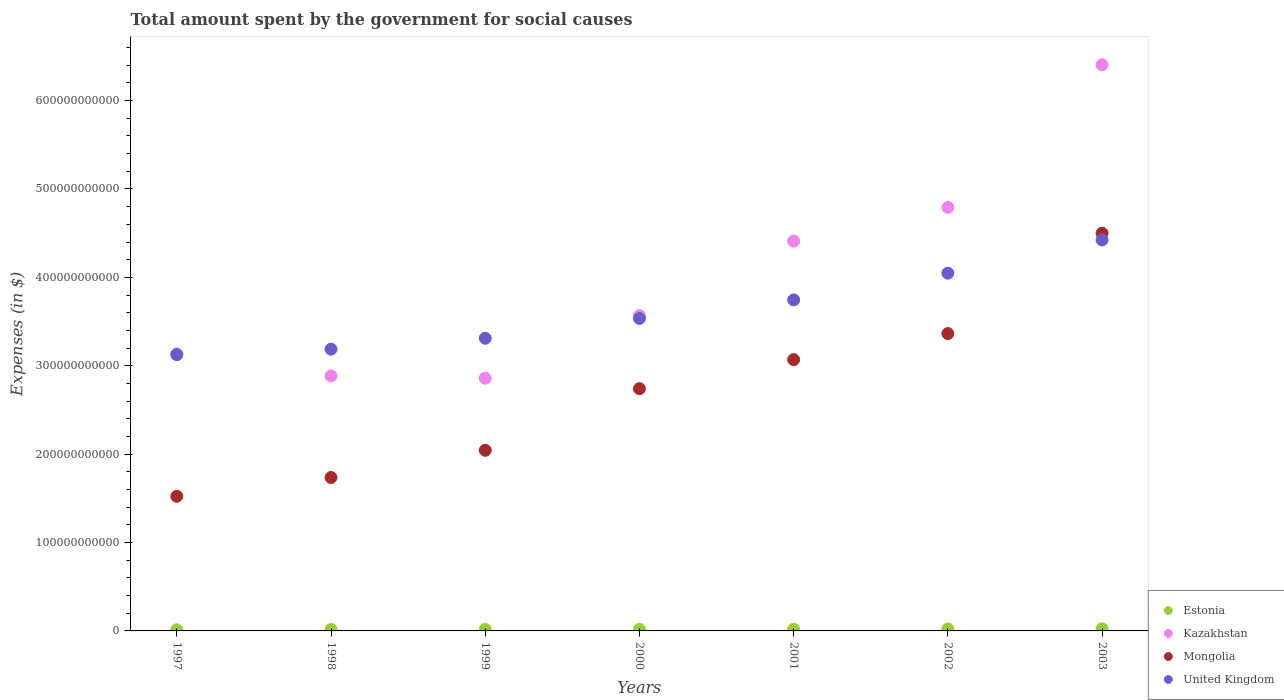How many different coloured dotlines are there?
Offer a very short reply. 4. Is the number of dotlines equal to the number of legend labels?
Give a very brief answer. Yes. What is the amount spent for social causes by the government in Mongolia in 1999?
Provide a succinct answer. 2.04e+11. Across all years, what is the maximum amount spent for social causes by the government in Estonia?
Give a very brief answer. 2.40e+09. Across all years, what is the minimum amount spent for social causes by the government in United Kingdom?
Offer a very short reply. 3.13e+11. In which year was the amount spent for social causes by the government in Kazakhstan maximum?
Ensure brevity in your answer.  2003. What is the total amount spent for social causes by the government in Estonia in the graph?
Your answer should be compact. 1.29e+1. What is the difference between the amount spent for social causes by the government in Kazakhstan in 2000 and that in 2001?
Offer a terse response. -8.43e+1. What is the difference between the amount spent for social causes by the government in Mongolia in 1998 and the amount spent for social causes by the government in Estonia in 2002?
Your answer should be compact. 1.71e+11. What is the average amount spent for social causes by the government in United Kingdom per year?
Ensure brevity in your answer.  3.63e+11. In the year 1997, what is the difference between the amount spent for social causes by the government in Estonia and amount spent for social causes by the government in Kazakhstan?
Your answer should be very brief. -3.12e+11. What is the ratio of the amount spent for social causes by the government in Estonia in 1998 to that in 2002?
Ensure brevity in your answer.  0.73. Is the difference between the amount spent for social causes by the government in Estonia in 1998 and 1999 greater than the difference between the amount spent for social causes by the government in Kazakhstan in 1998 and 1999?
Keep it short and to the point. No. What is the difference between the highest and the second highest amount spent for social causes by the government in United Kingdom?
Ensure brevity in your answer.  3.76e+1. What is the difference between the highest and the lowest amount spent for social causes by the government in Kazakhstan?
Provide a short and direct response. 3.54e+11. Is it the case that in every year, the sum of the amount spent for social causes by the government in Kazakhstan and amount spent for social causes by the government in United Kingdom  is greater than the sum of amount spent for social causes by the government in Estonia and amount spent for social causes by the government in Mongolia?
Your answer should be very brief. Yes. Is it the case that in every year, the sum of the amount spent for social causes by the government in Kazakhstan and amount spent for social causes by the government in Estonia  is greater than the amount spent for social causes by the government in United Kingdom?
Your answer should be compact. No. Is the amount spent for social causes by the government in Kazakhstan strictly greater than the amount spent for social causes by the government in Estonia over the years?
Make the answer very short. Yes. How many dotlines are there?
Provide a short and direct response. 4. How many years are there in the graph?
Offer a terse response. 7. What is the difference between two consecutive major ticks on the Y-axis?
Your answer should be very brief. 1.00e+11. Does the graph contain grids?
Keep it short and to the point. No. Where does the legend appear in the graph?
Provide a succinct answer. Bottom right. How are the legend labels stacked?
Offer a very short reply. Vertical. What is the title of the graph?
Offer a terse response. Total amount spent by the government for social causes. Does "South Africa" appear as one of the legend labels in the graph?
Your answer should be very brief. No. What is the label or title of the X-axis?
Keep it short and to the point. Years. What is the label or title of the Y-axis?
Offer a very short reply. Expenses (in $). What is the Expenses (in $) of Estonia in 1997?
Your response must be concise. 1.33e+09. What is the Expenses (in $) of Kazakhstan in 1997?
Provide a short and direct response. 3.13e+11. What is the Expenses (in $) in Mongolia in 1997?
Your response must be concise. 1.52e+11. What is the Expenses (in $) of United Kingdom in 1997?
Offer a very short reply. 3.13e+11. What is the Expenses (in $) of Estonia in 1998?
Give a very brief answer. 1.56e+09. What is the Expenses (in $) of Kazakhstan in 1998?
Ensure brevity in your answer.  2.89e+11. What is the Expenses (in $) in Mongolia in 1998?
Offer a terse response. 1.74e+11. What is the Expenses (in $) of United Kingdom in 1998?
Give a very brief answer. 3.19e+11. What is the Expenses (in $) in Estonia in 1999?
Provide a short and direct response. 1.75e+09. What is the Expenses (in $) of Kazakhstan in 1999?
Provide a short and direct response. 2.86e+11. What is the Expenses (in $) of Mongolia in 1999?
Ensure brevity in your answer.  2.04e+11. What is the Expenses (in $) in United Kingdom in 1999?
Give a very brief answer. 3.31e+11. What is the Expenses (in $) of Estonia in 2000?
Give a very brief answer. 1.82e+09. What is the Expenses (in $) in Kazakhstan in 2000?
Your answer should be very brief. 3.57e+11. What is the Expenses (in $) of Mongolia in 2000?
Provide a short and direct response. 2.74e+11. What is the Expenses (in $) in United Kingdom in 2000?
Your answer should be very brief. 3.54e+11. What is the Expenses (in $) of Estonia in 2001?
Ensure brevity in your answer.  1.93e+09. What is the Expenses (in $) of Kazakhstan in 2001?
Offer a terse response. 4.41e+11. What is the Expenses (in $) of Mongolia in 2001?
Offer a very short reply. 3.07e+11. What is the Expenses (in $) in United Kingdom in 2001?
Give a very brief answer. 3.75e+11. What is the Expenses (in $) of Estonia in 2002?
Provide a short and direct response. 2.15e+09. What is the Expenses (in $) in Kazakhstan in 2002?
Offer a very short reply. 4.79e+11. What is the Expenses (in $) in Mongolia in 2002?
Provide a succinct answer. 3.36e+11. What is the Expenses (in $) of United Kingdom in 2002?
Provide a succinct answer. 4.05e+11. What is the Expenses (in $) in Estonia in 2003?
Your answer should be very brief. 2.40e+09. What is the Expenses (in $) of Kazakhstan in 2003?
Keep it short and to the point. 6.40e+11. What is the Expenses (in $) of Mongolia in 2003?
Provide a short and direct response. 4.50e+11. What is the Expenses (in $) in United Kingdom in 2003?
Ensure brevity in your answer.  4.42e+11. Across all years, what is the maximum Expenses (in $) in Estonia?
Ensure brevity in your answer.  2.40e+09. Across all years, what is the maximum Expenses (in $) of Kazakhstan?
Provide a succinct answer. 6.40e+11. Across all years, what is the maximum Expenses (in $) in Mongolia?
Give a very brief answer. 4.50e+11. Across all years, what is the maximum Expenses (in $) of United Kingdom?
Keep it short and to the point. 4.42e+11. Across all years, what is the minimum Expenses (in $) of Estonia?
Offer a very short reply. 1.33e+09. Across all years, what is the minimum Expenses (in $) in Kazakhstan?
Keep it short and to the point. 2.86e+11. Across all years, what is the minimum Expenses (in $) of Mongolia?
Your answer should be very brief. 1.52e+11. Across all years, what is the minimum Expenses (in $) of United Kingdom?
Your response must be concise. 3.13e+11. What is the total Expenses (in $) of Estonia in the graph?
Keep it short and to the point. 1.29e+1. What is the total Expenses (in $) of Kazakhstan in the graph?
Your response must be concise. 2.81e+12. What is the total Expenses (in $) in Mongolia in the graph?
Offer a terse response. 1.90e+12. What is the total Expenses (in $) of United Kingdom in the graph?
Give a very brief answer. 2.54e+12. What is the difference between the Expenses (in $) of Estonia in 1997 and that in 1998?
Ensure brevity in your answer.  -2.32e+08. What is the difference between the Expenses (in $) of Kazakhstan in 1997 and that in 1998?
Your answer should be compact. 2.49e+1. What is the difference between the Expenses (in $) in Mongolia in 1997 and that in 1998?
Provide a short and direct response. -2.12e+1. What is the difference between the Expenses (in $) of United Kingdom in 1997 and that in 1998?
Provide a succinct answer. -6.18e+09. What is the difference between the Expenses (in $) of Estonia in 1997 and that in 1999?
Provide a short and direct response. -4.17e+08. What is the difference between the Expenses (in $) in Kazakhstan in 1997 and that in 1999?
Make the answer very short. 2.74e+1. What is the difference between the Expenses (in $) in Mongolia in 1997 and that in 1999?
Ensure brevity in your answer.  -5.20e+1. What is the difference between the Expenses (in $) in United Kingdom in 1997 and that in 1999?
Keep it short and to the point. -1.85e+1. What is the difference between the Expenses (in $) in Estonia in 1997 and that in 2000?
Keep it short and to the point. -4.85e+08. What is the difference between the Expenses (in $) of Kazakhstan in 1997 and that in 2000?
Ensure brevity in your answer.  -4.33e+1. What is the difference between the Expenses (in $) in Mongolia in 1997 and that in 2000?
Offer a terse response. -1.22e+11. What is the difference between the Expenses (in $) in United Kingdom in 1997 and that in 2000?
Give a very brief answer. -4.10e+1. What is the difference between the Expenses (in $) of Estonia in 1997 and that in 2001?
Give a very brief answer. -6.01e+08. What is the difference between the Expenses (in $) in Kazakhstan in 1997 and that in 2001?
Give a very brief answer. -1.28e+11. What is the difference between the Expenses (in $) of Mongolia in 1997 and that in 2001?
Offer a very short reply. -1.55e+11. What is the difference between the Expenses (in $) of United Kingdom in 1997 and that in 2001?
Ensure brevity in your answer.  -6.19e+1. What is the difference between the Expenses (in $) in Estonia in 1997 and that in 2002?
Offer a terse response. -8.13e+08. What is the difference between the Expenses (in $) of Kazakhstan in 1997 and that in 2002?
Offer a very short reply. -1.66e+11. What is the difference between the Expenses (in $) of Mongolia in 1997 and that in 2002?
Make the answer very short. -1.84e+11. What is the difference between the Expenses (in $) of United Kingdom in 1997 and that in 2002?
Provide a short and direct response. -9.22e+1. What is the difference between the Expenses (in $) of Estonia in 1997 and that in 2003?
Your answer should be compact. -1.07e+09. What is the difference between the Expenses (in $) of Kazakhstan in 1997 and that in 2003?
Provide a succinct answer. -3.27e+11. What is the difference between the Expenses (in $) in Mongolia in 1997 and that in 2003?
Your answer should be very brief. -2.98e+11. What is the difference between the Expenses (in $) of United Kingdom in 1997 and that in 2003?
Offer a very short reply. -1.30e+11. What is the difference between the Expenses (in $) of Estonia in 1998 and that in 1999?
Offer a terse response. -1.85e+08. What is the difference between the Expenses (in $) of Kazakhstan in 1998 and that in 1999?
Provide a short and direct response. 2.56e+09. What is the difference between the Expenses (in $) in Mongolia in 1998 and that in 1999?
Your answer should be compact. -3.08e+1. What is the difference between the Expenses (in $) of United Kingdom in 1998 and that in 1999?
Offer a very short reply. -1.24e+1. What is the difference between the Expenses (in $) in Estonia in 1998 and that in 2000?
Your response must be concise. -2.53e+08. What is the difference between the Expenses (in $) in Kazakhstan in 1998 and that in 2000?
Make the answer very short. -6.82e+1. What is the difference between the Expenses (in $) of Mongolia in 1998 and that in 2000?
Give a very brief answer. -1.00e+11. What is the difference between the Expenses (in $) of United Kingdom in 1998 and that in 2000?
Make the answer very short. -3.48e+1. What is the difference between the Expenses (in $) of Estonia in 1998 and that in 2001?
Provide a short and direct response. -3.69e+08. What is the difference between the Expenses (in $) in Kazakhstan in 1998 and that in 2001?
Provide a succinct answer. -1.53e+11. What is the difference between the Expenses (in $) of Mongolia in 1998 and that in 2001?
Give a very brief answer. -1.33e+11. What is the difference between the Expenses (in $) in United Kingdom in 1998 and that in 2001?
Offer a terse response. -5.58e+1. What is the difference between the Expenses (in $) of Estonia in 1998 and that in 2002?
Offer a very short reply. -5.81e+08. What is the difference between the Expenses (in $) of Kazakhstan in 1998 and that in 2002?
Give a very brief answer. -1.91e+11. What is the difference between the Expenses (in $) of Mongolia in 1998 and that in 2002?
Provide a succinct answer. -1.63e+11. What is the difference between the Expenses (in $) of United Kingdom in 1998 and that in 2002?
Your answer should be compact. -8.60e+1. What is the difference between the Expenses (in $) in Estonia in 1998 and that in 2003?
Provide a short and direct response. -8.36e+08. What is the difference between the Expenses (in $) in Kazakhstan in 1998 and that in 2003?
Make the answer very short. -3.52e+11. What is the difference between the Expenses (in $) of Mongolia in 1998 and that in 2003?
Your answer should be very brief. -2.76e+11. What is the difference between the Expenses (in $) of United Kingdom in 1998 and that in 2003?
Provide a short and direct response. -1.24e+11. What is the difference between the Expenses (in $) in Estonia in 1999 and that in 2000?
Your answer should be compact. -6.76e+07. What is the difference between the Expenses (in $) in Kazakhstan in 1999 and that in 2000?
Keep it short and to the point. -7.08e+1. What is the difference between the Expenses (in $) in Mongolia in 1999 and that in 2000?
Your response must be concise. -6.97e+1. What is the difference between the Expenses (in $) of United Kingdom in 1999 and that in 2000?
Your answer should be compact. -2.24e+1. What is the difference between the Expenses (in $) in Estonia in 1999 and that in 2001?
Your answer should be compact. -1.84e+08. What is the difference between the Expenses (in $) in Kazakhstan in 1999 and that in 2001?
Make the answer very short. -1.55e+11. What is the difference between the Expenses (in $) in Mongolia in 1999 and that in 2001?
Your response must be concise. -1.03e+11. What is the difference between the Expenses (in $) of United Kingdom in 1999 and that in 2001?
Your response must be concise. -4.34e+1. What is the difference between the Expenses (in $) in Estonia in 1999 and that in 2002?
Your answer should be very brief. -3.96e+08. What is the difference between the Expenses (in $) in Kazakhstan in 1999 and that in 2002?
Your answer should be compact. -1.93e+11. What is the difference between the Expenses (in $) of Mongolia in 1999 and that in 2002?
Your response must be concise. -1.32e+11. What is the difference between the Expenses (in $) in United Kingdom in 1999 and that in 2002?
Provide a short and direct response. -7.37e+1. What is the difference between the Expenses (in $) in Estonia in 1999 and that in 2003?
Your answer should be very brief. -6.51e+08. What is the difference between the Expenses (in $) in Kazakhstan in 1999 and that in 2003?
Offer a terse response. -3.54e+11. What is the difference between the Expenses (in $) in Mongolia in 1999 and that in 2003?
Give a very brief answer. -2.46e+11. What is the difference between the Expenses (in $) in United Kingdom in 1999 and that in 2003?
Make the answer very short. -1.11e+11. What is the difference between the Expenses (in $) of Estonia in 2000 and that in 2001?
Make the answer very short. -1.17e+08. What is the difference between the Expenses (in $) of Kazakhstan in 2000 and that in 2001?
Give a very brief answer. -8.43e+1. What is the difference between the Expenses (in $) in Mongolia in 2000 and that in 2001?
Your answer should be compact. -3.29e+1. What is the difference between the Expenses (in $) of United Kingdom in 2000 and that in 2001?
Give a very brief answer. -2.10e+1. What is the difference between the Expenses (in $) in Estonia in 2000 and that in 2002?
Give a very brief answer. -3.29e+08. What is the difference between the Expenses (in $) in Kazakhstan in 2000 and that in 2002?
Your answer should be compact. -1.23e+11. What is the difference between the Expenses (in $) in Mongolia in 2000 and that in 2002?
Ensure brevity in your answer.  -6.24e+1. What is the difference between the Expenses (in $) of United Kingdom in 2000 and that in 2002?
Offer a very short reply. -5.12e+1. What is the difference between the Expenses (in $) in Estonia in 2000 and that in 2003?
Keep it short and to the point. -5.83e+08. What is the difference between the Expenses (in $) of Kazakhstan in 2000 and that in 2003?
Your answer should be very brief. -2.84e+11. What is the difference between the Expenses (in $) of Mongolia in 2000 and that in 2003?
Your response must be concise. -1.76e+11. What is the difference between the Expenses (in $) of United Kingdom in 2000 and that in 2003?
Your response must be concise. -8.88e+1. What is the difference between the Expenses (in $) in Estonia in 2001 and that in 2002?
Provide a succinct answer. -2.12e+08. What is the difference between the Expenses (in $) of Kazakhstan in 2001 and that in 2002?
Ensure brevity in your answer.  -3.82e+1. What is the difference between the Expenses (in $) in Mongolia in 2001 and that in 2002?
Offer a very short reply. -2.95e+1. What is the difference between the Expenses (in $) of United Kingdom in 2001 and that in 2002?
Provide a short and direct response. -3.03e+1. What is the difference between the Expenses (in $) in Estonia in 2001 and that in 2003?
Give a very brief answer. -4.66e+08. What is the difference between the Expenses (in $) in Kazakhstan in 2001 and that in 2003?
Provide a succinct answer. -1.99e+11. What is the difference between the Expenses (in $) of Mongolia in 2001 and that in 2003?
Give a very brief answer. -1.43e+11. What is the difference between the Expenses (in $) of United Kingdom in 2001 and that in 2003?
Provide a short and direct response. -6.78e+1. What is the difference between the Expenses (in $) of Estonia in 2002 and that in 2003?
Give a very brief answer. -2.54e+08. What is the difference between the Expenses (in $) in Kazakhstan in 2002 and that in 2003?
Your response must be concise. -1.61e+11. What is the difference between the Expenses (in $) in Mongolia in 2002 and that in 2003?
Offer a terse response. -1.14e+11. What is the difference between the Expenses (in $) in United Kingdom in 2002 and that in 2003?
Make the answer very short. -3.76e+1. What is the difference between the Expenses (in $) in Estonia in 1997 and the Expenses (in $) in Kazakhstan in 1998?
Provide a short and direct response. -2.87e+11. What is the difference between the Expenses (in $) of Estonia in 1997 and the Expenses (in $) of Mongolia in 1998?
Ensure brevity in your answer.  -1.72e+11. What is the difference between the Expenses (in $) of Estonia in 1997 and the Expenses (in $) of United Kingdom in 1998?
Provide a succinct answer. -3.17e+11. What is the difference between the Expenses (in $) of Kazakhstan in 1997 and the Expenses (in $) of Mongolia in 1998?
Provide a short and direct response. 1.40e+11. What is the difference between the Expenses (in $) in Kazakhstan in 1997 and the Expenses (in $) in United Kingdom in 1998?
Offer a very short reply. -5.36e+09. What is the difference between the Expenses (in $) in Mongolia in 1997 and the Expenses (in $) in United Kingdom in 1998?
Make the answer very short. -1.66e+11. What is the difference between the Expenses (in $) in Estonia in 1997 and the Expenses (in $) in Kazakhstan in 1999?
Your response must be concise. -2.85e+11. What is the difference between the Expenses (in $) in Estonia in 1997 and the Expenses (in $) in Mongolia in 1999?
Your answer should be compact. -2.03e+11. What is the difference between the Expenses (in $) of Estonia in 1997 and the Expenses (in $) of United Kingdom in 1999?
Give a very brief answer. -3.30e+11. What is the difference between the Expenses (in $) of Kazakhstan in 1997 and the Expenses (in $) of Mongolia in 1999?
Offer a terse response. 1.09e+11. What is the difference between the Expenses (in $) in Kazakhstan in 1997 and the Expenses (in $) in United Kingdom in 1999?
Your answer should be compact. -1.77e+1. What is the difference between the Expenses (in $) in Mongolia in 1997 and the Expenses (in $) in United Kingdom in 1999?
Keep it short and to the point. -1.79e+11. What is the difference between the Expenses (in $) in Estonia in 1997 and the Expenses (in $) in Kazakhstan in 2000?
Provide a succinct answer. -3.55e+11. What is the difference between the Expenses (in $) of Estonia in 1997 and the Expenses (in $) of Mongolia in 2000?
Give a very brief answer. -2.73e+11. What is the difference between the Expenses (in $) in Estonia in 1997 and the Expenses (in $) in United Kingdom in 2000?
Offer a very short reply. -3.52e+11. What is the difference between the Expenses (in $) in Kazakhstan in 1997 and the Expenses (in $) in Mongolia in 2000?
Your answer should be very brief. 3.93e+1. What is the difference between the Expenses (in $) in Kazakhstan in 1997 and the Expenses (in $) in United Kingdom in 2000?
Your answer should be compact. -4.01e+1. What is the difference between the Expenses (in $) in Mongolia in 1997 and the Expenses (in $) in United Kingdom in 2000?
Keep it short and to the point. -2.01e+11. What is the difference between the Expenses (in $) in Estonia in 1997 and the Expenses (in $) in Kazakhstan in 2001?
Keep it short and to the point. -4.40e+11. What is the difference between the Expenses (in $) in Estonia in 1997 and the Expenses (in $) in Mongolia in 2001?
Keep it short and to the point. -3.06e+11. What is the difference between the Expenses (in $) of Estonia in 1997 and the Expenses (in $) of United Kingdom in 2001?
Provide a short and direct response. -3.73e+11. What is the difference between the Expenses (in $) in Kazakhstan in 1997 and the Expenses (in $) in Mongolia in 2001?
Your answer should be compact. 6.47e+09. What is the difference between the Expenses (in $) of Kazakhstan in 1997 and the Expenses (in $) of United Kingdom in 2001?
Your answer should be very brief. -6.11e+1. What is the difference between the Expenses (in $) of Mongolia in 1997 and the Expenses (in $) of United Kingdom in 2001?
Your answer should be compact. -2.22e+11. What is the difference between the Expenses (in $) in Estonia in 1997 and the Expenses (in $) in Kazakhstan in 2002?
Provide a short and direct response. -4.78e+11. What is the difference between the Expenses (in $) in Estonia in 1997 and the Expenses (in $) in Mongolia in 2002?
Give a very brief answer. -3.35e+11. What is the difference between the Expenses (in $) in Estonia in 1997 and the Expenses (in $) in United Kingdom in 2002?
Offer a very short reply. -4.03e+11. What is the difference between the Expenses (in $) in Kazakhstan in 1997 and the Expenses (in $) in Mongolia in 2002?
Make the answer very short. -2.30e+1. What is the difference between the Expenses (in $) in Kazakhstan in 1997 and the Expenses (in $) in United Kingdom in 2002?
Offer a very short reply. -9.14e+1. What is the difference between the Expenses (in $) of Mongolia in 1997 and the Expenses (in $) of United Kingdom in 2002?
Keep it short and to the point. -2.52e+11. What is the difference between the Expenses (in $) in Estonia in 1997 and the Expenses (in $) in Kazakhstan in 2003?
Keep it short and to the point. -6.39e+11. What is the difference between the Expenses (in $) of Estonia in 1997 and the Expenses (in $) of Mongolia in 2003?
Give a very brief answer. -4.49e+11. What is the difference between the Expenses (in $) in Estonia in 1997 and the Expenses (in $) in United Kingdom in 2003?
Keep it short and to the point. -4.41e+11. What is the difference between the Expenses (in $) in Kazakhstan in 1997 and the Expenses (in $) in Mongolia in 2003?
Keep it short and to the point. -1.37e+11. What is the difference between the Expenses (in $) of Kazakhstan in 1997 and the Expenses (in $) of United Kingdom in 2003?
Your answer should be compact. -1.29e+11. What is the difference between the Expenses (in $) of Mongolia in 1997 and the Expenses (in $) of United Kingdom in 2003?
Offer a terse response. -2.90e+11. What is the difference between the Expenses (in $) in Estonia in 1998 and the Expenses (in $) in Kazakhstan in 1999?
Your answer should be very brief. -2.84e+11. What is the difference between the Expenses (in $) in Estonia in 1998 and the Expenses (in $) in Mongolia in 1999?
Provide a short and direct response. -2.03e+11. What is the difference between the Expenses (in $) in Estonia in 1998 and the Expenses (in $) in United Kingdom in 1999?
Make the answer very short. -3.30e+11. What is the difference between the Expenses (in $) in Kazakhstan in 1998 and the Expenses (in $) in Mongolia in 1999?
Make the answer very short. 8.42e+1. What is the difference between the Expenses (in $) in Kazakhstan in 1998 and the Expenses (in $) in United Kingdom in 1999?
Make the answer very short. -4.26e+1. What is the difference between the Expenses (in $) of Mongolia in 1998 and the Expenses (in $) of United Kingdom in 1999?
Ensure brevity in your answer.  -1.58e+11. What is the difference between the Expenses (in $) in Estonia in 1998 and the Expenses (in $) in Kazakhstan in 2000?
Your answer should be compact. -3.55e+11. What is the difference between the Expenses (in $) of Estonia in 1998 and the Expenses (in $) of Mongolia in 2000?
Give a very brief answer. -2.72e+11. What is the difference between the Expenses (in $) in Estonia in 1998 and the Expenses (in $) in United Kingdom in 2000?
Your response must be concise. -3.52e+11. What is the difference between the Expenses (in $) in Kazakhstan in 1998 and the Expenses (in $) in Mongolia in 2000?
Provide a short and direct response. 1.45e+1. What is the difference between the Expenses (in $) in Kazakhstan in 1998 and the Expenses (in $) in United Kingdom in 2000?
Provide a short and direct response. -6.50e+1. What is the difference between the Expenses (in $) in Mongolia in 1998 and the Expenses (in $) in United Kingdom in 2000?
Provide a succinct answer. -1.80e+11. What is the difference between the Expenses (in $) in Estonia in 1998 and the Expenses (in $) in Kazakhstan in 2001?
Give a very brief answer. -4.39e+11. What is the difference between the Expenses (in $) of Estonia in 1998 and the Expenses (in $) of Mongolia in 2001?
Make the answer very short. -3.05e+11. What is the difference between the Expenses (in $) in Estonia in 1998 and the Expenses (in $) in United Kingdom in 2001?
Offer a very short reply. -3.73e+11. What is the difference between the Expenses (in $) in Kazakhstan in 1998 and the Expenses (in $) in Mongolia in 2001?
Your answer should be very brief. -1.84e+1. What is the difference between the Expenses (in $) in Kazakhstan in 1998 and the Expenses (in $) in United Kingdom in 2001?
Offer a terse response. -8.60e+1. What is the difference between the Expenses (in $) of Mongolia in 1998 and the Expenses (in $) of United Kingdom in 2001?
Your response must be concise. -2.01e+11. What is the difference between the Expenses (in $) in Estonia in 1998 and the Expenses (in $) in Kazakhstan in 2002?
Offer a terse response. -4.78e+11. What is the difference between the Expenses (in $) of Estonia in 1998 and the Expenses (in $) of Mongolia in 2002?
Your answer should be compact. -3.35e+11. What is the difference between the Expenses (in $) in Estonia in 1998 and the Expenses (in $) in United Kingdom in 2002?
Keep it short and to the point. -4.03e+11. What is the difference between the Expenses (in $) of Kazakhstan in 1998 and the Expenses (in $) of Mongolia in 2002?
Ensure brevity in your answer.  -4.79e+1. What is the difference between the Expenses (in $) of Kazakhstan in 1998 and the Expenses (in $) of United Kingdom in 2002?
Ensure brevity in your answer.  -1.16e+11. What is the difference between the Expenses (in $) of Mongolia in 1998 and the Expenses (in $) of United Kingdom in 2002?
Provide a succinct answer. -2.31e+11. What is the difference between the Expenses (in $) in Estonia in 1998 and the Expenses (in $) in Kazakhstan in 2003?
Your response must be concise. -6.39e+11. What is the difference between the Expenses (in $) in Estonia in 1998 and the Expenses (in $) in Mongolia in 2003?
Offer a very short reply. -4.48e+11. What is the difference between the Expenses (in $) in Estonia in 1998 and the Expenses (in $) in United Kingdom in 2003?
Ensure brevity in your answer.  -4.41e+11. What is the difference between the Expenses (in $) of Kazakhstan in 1998 and the Expenses (in $) of Mongolia in 2003?
Offer a terse response. -1.61e+11. What is the difference between the Expenses (in $) of Kazakhstan in 1998 and the Expenses (in $) of United Kingdom in 2003?
Your answer should be compact. -1.54e+11. What is the difference between the Expenses (in $) of Mongolia in 1998 and the Expenses (in $) of United Kingdom in 2003?
Provide a succinct answer. -2.69e+11. What is the difference between the Expenses (in $) in Estonia in 1999 and the Expenses (in $) in Kazakhstan in 2000?
Give a very brief answer. -3.55e+11. What is the difference between the Expenses (in $) of Estonia in 1999 and the Expenses (in $) of Mongolia in 2000?
Your response must be concise. -2.72e+11. What is the difference between the Expenses (in $) of Estonia in 1999 and the Expenses (in $) of United Kingdom in 2000?
Offer a terse response. -3.52e+11. What is the difference between the Expenses (in $) in Kazakhstan in 1999 and the Expenses (in $) in Mongolia in 2000?
Keep it short and to the point. 1.19e+1. What is the difference between the Expenses (in $) in Kazakhstan in 1999 and the Expenses (in $) in United Kingdom in 2000?
Your answer should be compact. -6.76e+1. What is the difference between the Expenses (in $) in Mongolia in 1999 and the Expenses (in $) in United Kingdom in 2000?
Provide a succinct answer. -1.49e+11. What is the difference between the Expenses (in $) in Estonia in 1999 and the Expenses (in $) in Kazakhstan in 2001?
Your answer should be compact. -4.39e+11. What is the difference between the Expenses (in $) in Estonia in 1999 and the Expenses (in $) in Mongolia in 2001?
Ensure brevity in your answer.  -3.05e+11. What is the difference between the Expenses (in $) of Estonia in 1999 and the Expenses (in $) of United Kingdom in 2001?
Provide a short and direct response. -3.73e+11. What is the difference between the Expenses (in $) in Kazakhstan in 1999 and the Expenses (in $) in Mongolia in 2001?
Your answer should be very brief. -2.09e+1. What is the difference between the Expenses (in $) of Kazakhstan in 1999 and the Expenses (in $) of United Kingdom in 2001?
Keep it short and to the point. -8.85e+1. What is the difference between the Expenses (in $) in Mongolia in 1999 and the Expenses (in $) in United Kingdom in 2001?
Give a very brief answer. -1.70e+11. What is the difference between the Expenses (in $) in Estonia in 1999 and the Expenses (in $) in Kazakhstan in 2002?
Provide a succinct answer. -4.78e+11. What is the difference between the Expenses (in $) of Estonia in 1999 and the Expenses (in $) of Mongolia in 2002?
Your response must be concise. -3.35e+11. What is the difference between the Expenses (in $) of Estonia in 1999 and the Expenses (in $) of United Kingdom in 2002?
Give a very brief answer. -4.03e+11. What is the difference between the Expenses (in $) of Kazakhstan in 1999 and the Expenses (in $) of Mongolia in 2002?
Make the answer very short. -5.05e+1. What is the difference between the Expenses (in $) of Kazakhstan in 1999 and the Expenses (in $) of United Kingdom in 2002?
Give a very brief answer. -1.19e+11. What is the difference between the Expenses (in $) of Mongolia in 1999 and the Expenses (in $) of United Kingdom in 2002?
Offer a very short reply. -2.00e+11. What is the difference between the Expenses (in $) in Estonia in 1999 and the Expenses (in $) in Kazakhstan in 2003?
Your answer should be very brief. -6.39e+11. What is the difference between the Expenses (in $) of Estonia in 1999 and the Expenses (in $) of Mongolia in 2003?
Give a very brief answer. -4.48e+11. What is the difference between the Expenses (in $) of Estonia in 1999 and the Expenses (in $) of United Kingdom in 2003?
Your answer should be compact. -4.41e+11. What is the difference between the Expenses (in $) of Kazakhstan in 1999 and the Expenses (in $) of Mongolia in 2003?
Your answer should be very brief. -1.64e+11. What is the difference between the Expenses (in $) in Kazakhstan in 1999 and the Expenses (in $) in United Kingdom in 2003?
Your response must be concise. -1.56e+11. What is the difference between the Expenses (in $) in Mongolia in 1999 and the Expenses (in $) in United Kingdom in 2003?
Your answer should be compact. -2.38e+11. What is the difference between the Expenses (in $) of Estonia in 2000 and the Expenses (in $) of Kazakhstan in 2001?
Give a very brief answer. -4.39e+11. What is the difference between the Expenses (in $) of Estonia in 2000 and the Expenses (in $) of Mongolia in 2001?
Offer a terse response. -3.05e+11. What is the difference between the Expenses (in $) of Estonia in 2000 and the Expenses (in $) of United Kingdom in 2001?
Offer a very short reply. -3.73e+11. What is the difference between the Expenses (in $) in Kazakhstan in 2000 and the Expenses (in $) in Mongolia in 2001?
Provide a short and direct response. 4.98e+1. What is the difference between the Expenses (in $) of Kazakhstan in 2000 and the Expenses (in $) of United Kingdom in 2001?
Make the answer very short. -1.78e+1. What is the difference between the Expenses (in $) in Mongolia in 2000 and the Expenses (in $) in United Kingdom in 2001?
Offer a terse response. -1.00e+11. What is the difference between the Expenses (in $) in Estonia in 2000 and the Expenses (in $) in Kazakhstan in 2002?
Provide a short and direct response. -4.77e+11. What is the difference between the Expenses (in $) in Estonia in 2000 and the Expenses (in $) in Mongolia in 2002?
Your answer should be compact. -3.35e+11. What is the difference between the Expenses (in $) in Estonia in 2000 and the Expenses (in $) in United Kingdom in 2002?
Make the answer very short. -4.03e+11. What is the difference between the Expenses (in $) in Kazakhstan in 2000 and the Expenses (in $) in Mongolia in 2002?
Provide a succinct answer. 2.03e+1. What is the difference between the Expenses (in $) of Kazakhstan in 2000 and the Expenses (in $) of United Kingdom in 2002?
Give a very brief answer. -4.80e+1. What is the difference between the Expenses (in $) of Mongolia in 2000 and the Expenses (in $) of United Kingdom in 2002?
Ensure brevity in your answer.  -1.31e+11. What is the difference between the Expenses (in $) in Estonia in 2000 and the Expenses (in $) in Kazakhstan in 2003?
Offer a terse response. -6.39e+11. What is the difference between the Expenses (in $) in Estonia in 2000 and the Expenses (in $) in Mongolia in 2003?
Your response must be concise. -4.48e+11. What is the difference between the Expenses (in $) in Estonia in 2000 and the Expenses (in $) in United Kingdom in 2003?
Offer a very short reply. -4.41e+11. What is the difference between the Expenses (in $) of Kazakhstan in 2000 and the Expenses (in $) of Mongolia in 2003?
Provide a succinct answer. -9.32e+1. What is the difference between the Expenses (in $) in Kazakhstan in 2000 and the Expenses (in $) in United Kingdom in 2003?
Offer a terse response. -8.56e+1. What is the difference between the Expenses (in $) of Mongolia in 2000 and the Expenses (in $) of United Kingdom in 2003?
Offer a terse response. -1.68e+11. What is the difference between the Expenses (in $) of Estonia in 2001 and the Expenses (in $) of Kazakhstan in 2002?
Offer a terse response. -4.77e+11. What is the difference between the Expenses (in $) of Estonia in 2001 and the Expenses (in $) of Mongolia in 2002?
Ensure brevity in your answer.  -3.35e+11. What is the difference between the Expenses (in $) in Estonia in 2001 and the Expenses (in $) in United Kingdom in 2002?
Provide a short and direct response. -4.03e+11. What is the difference between the Expenses (in $) in Kazakhstan in 2001 and the Expenses (in $) in Mongolia in 2002?
Provide a succinct answer. 1.05e+11. What is the difference between the Expenses (in $) of Kazakhstan in 2001 and the Expenses (in $) of United Kingdom in 2002?
Your answer should be very brief. 3.63e+1. What is the difference between the Expenses (in $) of Mongolia in 2001 and the Expenses (in $) of United Kingdom in 2002?
Provide a succinct answer. -9.78e+1. What is the difference between the Expenses (in $) in Estonia in 2001 and the Expenses (in $) in Kazakhstan in 2003?
Offer a very short reply. -6.39e+11. What is the difference between the Expenses (in $) in Estonia in 2001 and the Expenses (in $) in Mongolia in 2003?
Offer a terse response. -4.48e+11. What is the difference between the Expenses (in $) of Estonia in 2001 and the Expenses (in $) of United Kingdom in 2003?
Your answer should be very brief. -4.40e+11. What is the difference between the Expenses (in $) in Kazakhstan in 2001 and the Expenses (in $) in Mongolia in 2003?
Offer a terse response. -8.91e+09. What is the difference between the Expenses (in $) in Kazakhstan in 2001 and the Expenses (in $) in United Kingdom in 2003?
Offer a very short reply. -1.27e+09. What is the difference between the Expenses (in $) of Mongolia in 2001 and the Expenses (in $) of United Kingdom in 2003?
Provide a succinct answer. -1.35e+11. What is the difference between the Expenses (in $) of Estonia in 2002 and the Expenses (in $) of Kazakhstan in 2003?
Your answer should be very brief. -6.38e+11. What is the difference between the Expenses (in $) in Estonia in 2002 and the Expenses (in $) in Mongolia in 2003?
Your response must be concise. -4.48e+11. What is the difference between the Expenses (in $) of Estonia in 2002 and the Expenses (in $) of United Kingdom in 2003?
Make the answer very short. -4.40e+11. What is the difference between the Expenses (in $) of Kazakhstan in 2002 and the Expenses (in $) of Mongolia in 2003?
Your response must be concise. 2.93e+1. What is the difference between the Expenses (in $) of Kazakhstan in 2002 and the Expenses (in $) of United Kingdom in 2003?
Provide a short and direct response. 3.69e+1. What is the difference between the Expenses (in $) of Mongolia in 2002 and the Expenses (in $) of United Kingdom in 2003?
Your answer should be very brief. -1.06e+11. What is the average Expenses (in $) of Estonia per year?
Your answer should be very brief. 1.85e+09. What is the average Expenses (in $) in Kazakhstan per year?
Give a very brief answer. 4.01e+11. What is the average Expenses (in $) of Mongolia per year?
Provide a succinct answer. 2.71e+11. What is the average Expenses (in $) of United Kingdom per year?
Make the answer very short. 3.63e+11. In the year 1997, what is the difference between the Expenses (in $) of Estonia and Expenses (in $) of Kazakhstan?
Offer a very short reply. -3.12e+11. In the year 1997, what is the difference between the Expenses (in $) in Estonia and Expenses (in $) in Mongolia?
Your answer should be compact. -1.51e+11. In the year 1997, what is the difference between the Expenses (in $) in Estonia and Expenses (in $) in United Kingdom?
Make the answer very short. -3.11e+11. In the year 1997, what is the difference between the Expenses (in $) in Kazakhstan and Expenses (in $) in Mongolia?
Make the answer very short. 1.61e+11. In the year 1997, what is the difference between the Expenses (in $) of Kazakhstan and Expenses (in $) of United Kingdom?
Give a very brief answer. 8.28e+08. In the year 1997, what is the difference between the Expenses (in $) of Mongolia and Expenses (in $) of United Kingdom?
Offer a terse response. -1.60e+11. In the year 1998, what is the difference between the Expenses (in $) in Estonia and Expenses (in $) in Kazakhstan?
Your answer should be compact. -2.87e+11. In the year 1998, what is the difference between the Expenses (in $) of Estonia and Expenses (in $) of Mongolia?
Provide a succinct answer. -1.72e+11. In the year 1998, what is the difference between the Expenses (in $) in Estonia and Expenses (in $) in United Kingdom?
Keep it short and to the point. -3.17e+11. In the year 1998, what is the difference between the Expenses (in $) in Kazakhstan and Expenses (in $) in Mongolia?
Your answer should be compact. 1.15e+11. In the year 1998, what is the difference between the Expenses (in $) in Kazakhstan and Expenses (in $) in United Kingdom?
Your answer should be compact. -3.02e+1. In the year 1998, what is the difference between the Expenses (in $) of Mongolia and Expenses (in $) of United Kingdom?
Make the answer very short. -1.45e+11. In the year 1999, what is the difference between the Expenses (in $) in Estonia and Expenses (in $) in Kazakhstan?
Offer a very short reply. -2.84e+11. In the year 1999, what is the difference between the Expenses (in $) in Estonia and Expenses (in $) in Mongolia?
Provide a succinct answer. -2.03e+11. In the year 1999, what is the difference between the Expenses (in $) of Estonia and Expenses (in $) of United Kingdom?
Offer a terse response. -3.29e+11. In the year 1999, what is the difference between the Expenses (in $) in Kazakhstan and Expenses (in $) in Mongolia?
Your answer should be very brief. 8.16e+1. In the year 1999, what is the difference between the Expenses (in $) in Kazakhstan and Expenses (in $) in United Kingdom?
Your response must be concise. -4.51e+1. In the year 1999, what is the difference between the Expenses (in $) in Mongolia and Expenses (in $) in United Kingdom?
Offer a very short reply. -1.27e+11. In the year 2000, what is the difference between the Expenses (in $) of Estonia and Expenses (in $) of Kazakhstan?
Make the answer very short. -3.55e+11. In the year 2000, what is the difference between the Expenses (in $) in Estonia and Expenses (in $) in Mongolia?
Offer a terse response. -2.72e+11. In the year 2000, what is the difference between the Expenses (in $) in Estonia and Expenses (in $) in United Kingdom?
Ensure brevity in your answer.  -3.52e+11. In the year 2000, what is the difference between the Expenses (in $) of Kazakhstan and Expenses (in $) of Mongolia?
Give a very brief answer. 8.27e+1. In the year 2000, what is the difference between the Expenses (in $) in Kazakhstan and Expenses (in $) in United Kingdom?
Your answer should be compact. 3.21e+09. In the year 2000, what is the difference between the Expenses (in $) in Mongolia and Expenses (in $) in United Kingdom?
Make the answer very short. -7.95e+1. In the year 2001, what is the difference between the Expenses (in $) of Estonia and Expenses (in $) of Kazakhstan?
Ensure brevity in your answer.  -4.39e+11. In the year 2001, what is the difference between the Expenses (in $) of Estonia and Expenses (in $) of Mongolia?
Your answer should be very brief. -3.05e+11. In the year 2001, what is the difference between the Expenses (in $) in Estonia and Expenses (in $) in United Kingdom?
Your answer should be compact. -3.73e+11. In the year 2001, what is the difference between the Expenses (in $) of Kazakhstan and Expenses (in $) of Mongolia?
Give a very brief answer. 1.34e+11. In the year 2001, what is the difference between the Expenses (in $) of Kazakhstan and Expenses (in $) of United Kingdom?
Offer a terse response. 6.65e+1. In the year 2001, what is the difference between the Expenses (in $) in Mongolia and Expenses (in $) in United Kingdom?
Provide a short and direct response. -6.76e+1. In the year 2002, what is the difference between the Expenses (in $) in Estonia and Expenses (in $) in Kazakhstan?
Offer a terse response. -4.77e+11. In the year 2002, what is the difference between the Expenses (in $) in Estonia and Expenses (in $) in Mongolia?
Your answer should be compact. -3.34e+11. In the year 2002, what is the difference between the Expenses (in $) of Estonia and Expenses (in $) of United Kingdom?
Provide a succinct answer. -4.03e+11. In the year 2002, what is the difference between the Expenses (in $) in Kazakhstan and Expenses (in $) in Mongolia?
Give a very brief answer. 1.43e+11. In the year 2002, what is the difference between the Expenses (in $) of Kazakhstan and Expenses (in $) of United Kingdom?
Provide a short and direct response. 7.45e+1. In the year 2002, what is the difference between the Expenses (in $) of Mongolia and Expenses (in $) of United Kingdom?
Provide a succinct answer. -6.83e+1. In the year 2003, what is the difference between the Expenses (in $) in Estonia and Expenses (in $) in Kazakhstan?
Provide a succinct answer. -6.38e+11. In the year 2003, what is the difference between the Expenses (in $) of Estonia and Expenses (in $) of Mongolia?
Give a very brief answer. -4.48e+11. In the year 2003, what is the difference between the Expenses (in $) in Estonia and Expenses (in $) in United Kingdom?
Give a very brief answer. -4.40e+11. In the year 2003, what is the difference between the Expenses (in $) in Kazakhstan and Expenses (in $) in Mongolia?
Provide a short and direct response. 1.91e+11. In the year 2003, what is the difference between the Expenses (in $) in Kazakhstan and Expenses (in $) in United Kingdom?
Make the answer very short. 1.98e+11. In the year 2003, what is the difference between the Expenses (in $) in Mongolia and Expenses (in $) in United Kingdom?
Offer a terse response. 7.64e+09. What is the ratio of the Expenses (in $) of Estonia in 1997 to that in 1998?
Give a very brief answer. 0.85. What is the ratio of the Expenses (in $) of Kazakhstan in 1997 to that in 1998?
Your response must be concise. 1.09. What is the ratio of the Expenses (in $) of Mongolia in 1997 to that in 1998?
Your answer should be very brief. 0.88. What is the ratio of the Expenses (in $) in United Kingdom in 1997 to that in 1998?
Provide a succinct answer. 0.98. What is the ratio of the Expenses (in $) of Estonia in 1997 to that in 1999?
Give a very brief answer. 0.76. What is the ratio of the Expenses (in $) in Kazakhstan in 1997 to that in 1999?
Provide a succinct answer. 1.1. What is the ratio of the Expenses (in $) in Mongolia in 1997 to that in 1999?
Keep it short and to the point. 0.75. What is the ratio of the Expenses (in $) in United Kingdom in 1997 to that in 1999?
Offer a terse response. 0.94. What is the ratio of the Expenses (in $) in Estonia in 1997 to that in 2000?
Your answer should be compact. 0.73. What is the ratio of the Expenses (in $) in Kazakhstan in 1997 to that in 2000?
Provide a succinct answer. 0.88. What is the ratio of the Expenses (in $) of Mongolia in 1997 to that in 2000?
Offer a very short reply. 0.56. What is the ratio of the Expenses (in $) of United Kingdom in 1997 to that in 2000?
Offer a very short reply. 0.88. What is the ratio of the Expenses (in $) of Estonia in 1997 to that in 2001?
Your response must be concise. 0.69. What is the ratio of the Expenses (in $) of Kazakhstan in 1997 to that in 2001?
Offer a terse response. 0.71. What is the ratio of the Expenses (in $) of Mongolia in 1997 to that in 2001?
Give a very brief answer. 0.5. What is the ratio of the Expenses (in $) of United Kingdom in 1997 to that in 2001?
Provide a succinct answer. 0.83. What is the ratio of the Expenses (in $) of Estonia in 1997 to that in 2002?
Provide a succinct answer. 0.62. What is the ratio of the Expenses (in $) in Kazakhstan in 1997 to that in 2002?
Provide a short and direct response. 0.65. What is the ratio of the Expenses (in $) in Mongolia in 1997 to that in 2002?
Provide a succinct answer. 0.45. What is the ratio of the Expenses (in $) in United Kingdom in 1997 to that in 2002?
Provide a succinct answer. 0.77. What is the ratio of the Expenses (in $) of Estonia in 1997 to that in 2003?
Ensure brevity in your answer.  0.56. What is the ratio of the Expenses (in $) in Kazakhstan in 1997 to that in 2003?
Your answer should be compact. 0.49. What is the ratio of the Expenses (in $) in Mongolia in 1997 to that in 2003?
Your answer should be very brief. 0.34. What is the ratio of the Expenses (in $) in United Kingdom in 1997 to that in 2003?
Give a very brief answer. 0.71. What is the ratio of the Expenses (in $) of Estonia in 1998 to that in 1999?
Your answer should be compact. 0.89. What is the ratio of the Expenses (in $) in Mongolia in 1998 to that in 1999?
Ensure brevity in your answer.  0.85. What is the ratio of the Expenses (in $) of United Kingdom in 1998 to that in 1999?
Your answer should be very brief. 0.96. What is the ratio of the Expenses (in $) of Estonia in 1998 to that in 2000?
Ensure brevity in your answer.  0.86. What is the ratio of the Expenses (in $) of Kazakhstan in 1998 to that in 2000?
Your response must be concise. 0.81. What is the ratio of the Expenses (in $) in Mongolia in 1998 to that in 2000?
Make the answer very short. 0.63. What is the ratio of the Expenses (in $) in United Kingdom in 1998 to that in 2000?
Offer a terse response. 0.9. What is the ratio of the Expenses (in $) in Estonia in 1998 to that in 2001?
Provide a short and direct response. 0.81. What is the ratio of the Expenses (in $) of Kazakhstan in 1998 to that in 2001?
Your answer should be compact. 0.65. What is the ratio of the Expenses (in $) in Mongolia in 1998 to that in 2001?
Keep it short and to the point. 0.57. What is the ratio of the Expenses (in $) of United Kingdom in 1998 to that in 2001?
Provide a short and direct response. 0.85. What is the ratio of the Expenses (in $) of Estonia in 1998 to that in 2002?
Provide a succinct answer. 0.73. What is the ratio of the Expenses (in $) of Kazakhstan in 1998 to that in 2002?
Offer a terse response. 0.6. What is the ratio of the Expenses (in $) in Mongolia in 1998 to that in 2002?
Your response must be concise. 0.52. What is the ratio of the Expenses (in $) in United Kingdom in 1998 to that in 2002?
Your response must be concise. 0.79. What is the ratio of the Expenses (in $) of Estonia in 1998 to that in 2003?
Provide a short and direct response. 0.65. What is the ratio of the Expenses (in $) of Kazakhstan in 1998 to that in 2003?
Provide a short and direct response. 0.45. What is the ratio of the Expenses (in $) of Mongolia in 1998 to that in 2003?
Offer a very short reply. 0.39. What is the ratio of the Expenses (in $) in United Kingdom in 1998 to that in 2003?
Ensure brevity in your answer.  0.72. What is the ratio of the Expenses (in $) in Estonia in 1999 to that in 2000?
Provide a succinct answer. 0.96. What is the ratio of the Expenses (in $) of Kazakhstan in 1999 to that in 2000?
Offer a terse response. 0.8. What is the ratio of the Expenses (in $) of Mongolia in 1999 to that in 2000?
Provide a succinct answer. 0.75. What is the ratio of the Expenses (in $) in United Kingdom in 1999 to that in 2000?
Provide a succinct answer. 0.94. What is the ratio of the Expenses (in $) in Estonia in 1999 to that in 2001?
Your answer should be compact. 0.9. What is the ratio of the Expenses (in $) in Kazakhstan in 1999 to that in 2001?
Your response must be concise. 0.65. What is the ratio of the Expenses (in $) of Mongolia in 1999 to that in 2001?
Your answer should be very brief. 0.67. What is the ratio of the Expenses (in $) in United Kingdom in 1999 to that in 2001?
Offer a very short reply. 0.88. What is the ratio of the Expenses (in $) of Estonia in 1999 to that in 2002?
Your response must be concise. 0.82. What is the ratio of the Expenses (in $) of Kazakhstan in 1999 to that in 2002?
Give a very brief answer. 0.6. What is the ratio of the Expenses (in $) in Mongolia in 1999 to that in 2002?
Your answer should be very brief. 0.61. What is the ratio of the Expenses (in $) of United Kingdom in 1999 to that in 2002?
Your response must be concise. 0.82. What is the ratio of the Expenses (in $) of Estonia in 1999 to that in 2003?
Provide a succinct answer. 0.73. What is the ratio of the Expenses (in $) in Kazakhstan in 1999 to that in 2003?
Ensure brevity in your answer.  0.45. What is the ratio of the Expenses (in $) of Mongolia in 1999 to that in 2003?
Your response must be concise. 0.45. What is the ratio of the Expenses (in $) of United Kingdom in 1999 to that in 2003?
Your answer should be compact. 0.75. What is the ratio of the Expenses (in $) of Estonia in 2000 to that in 2001?
Make the answer very short. 0.94. What is the ratio of the Expenses (in $) in Kazakhstan in 2000 to that in 2001?
Your response must be concise. 0.81. What is the ratio of the Expenses (in $) of Mongolia in 2000 to that in 2001?
Give a very brief answer. 0.89. What is the ratio of the Expenses (in $) of United Kingdom in 2000 to that in 2001?
Give a very brief answer. 0.94. What is the ratio of the Expenses (in $) in Estonia in 2000 to that in 2002?
Your answer should be very brief. 0.85. What is the ratio of the Expenses (in $) in Kazakhstan in 2000 to that in 2002?
Provide a succinct answer. 0.74. What is the ratio of the Expenses (in $) in Mongolia in 2000 to that in 2002?
Offer a very short reply. 0.81. What is the ratio of the Expenses (in $) in United Kingdom in 2000 to that in 2002?
Give a very brief answer. 0.87. What is the ratio of the Expenses (in $) of Estonia in 2000 to that in 2003?
Your answer should be very brief. 0.76. What is the ratio of the Expenses (in $) in Kazakhstan in 2000 to that in 2003?
Your response must be concise. 0.56. What is the ratio of the Expenses (in $) in Mongolia in 2000 to that in 2003?
Offer a terse response. 0.61. What is the ratio of the Expenses (in $) in United Kingdom in 2000 to that in 2003?
Your answer should be very brief. 0.8. What is the ratio of the Expenses (in $) in Estonia in 2001 to that in 2002?
Provide a succinct answer. 0.9. What is the ratio of the Expenses (in $) in Kazakhstan in 2001 to that in 2002?
Offer a terse response. 0.92. What is the ratio of the Expenses (in $) of Mongolia in 2001 to that in 2002?
Your answer should be very brief. 0.91. What is the ratio of the Expenses (in $) of United Kingdom in 2001 to that in 2002?
Make the answer very short. 0.93. What is the ratio of the Expenses (in $) of Estonia in 2001 to that in 2003?
Provide a short and direct response. 0.81. What is the ratio of the Expenses (in $) of Kazakhstan in 2001 to that in 2003?
Your answer should be very brief. 0.69. What is the ratio of the Expenses (in $) of Mongolia in 2001 to that in 2003?
Ensure brevity in your answer.  0.68. What is the ratio of the Expenses (in $) in United Kingdom in 2001 to that in 2003?
Offer a terse response. 0.85. What is the ratio of the Expenses (in $) in Estonia in 2002 to that in 2003?
Offer a terse response. 0.89. What is the ratio of the Expenses (in $) in Kazakhstan in 2002 to that in 2003?
Give a very brief answer. 0.75. What is the ratio of the Expenses (in $) of Mongolia in 2002 to that in 2003?
Offer a very short reply. 0.75. What is the ratio of the Expenses (in $) of United Kingdom in 2002 to that in 2003?
Offer a very short reply. 0.92. What is the difference between the highest and the second highest Expenses (in $) in Estonia?
Provide a short and direct response. 2.54e+08. What is the difference between the highest and the second highest Expenses (in $) in Kazakhstan?
Offer a terse response. 1.61e+11. What is the difference between the highest and the second highest Expenses (in $) of Mongolia?
Give a very brief answer. 1.14e+11. What is the difference between the highest and the second highest Expenses (in $) in United Kingdom?
Give a very brief answer. 3.76e+1. What is the difference between the highest and the lowest Expenses (in $) of Estonia?
Offer a terse response. 1.07e+09. What is the difference between the highest and the lowest Expenses (in $) in Kazakhstan?
Your answer should be very brief. 3.54e+11. What is the difference between the highest and the lowest Expenses (in $) of Mongolia?
Ensure brevity in your answer.  2.98e+11. What is the difference between the highest and the lowest Expenses (in $) of United Kingdom?
Your response must be concise. 1.30e+11. 